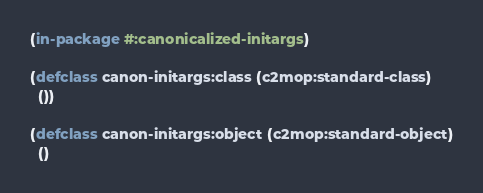<code> <loc_0><loc_0><loc_500><loc_500><_Lisp_>(in-package #:canonicalized-initargs)

(defclass canon-initargs:class (c2mop:standard-class)
  ())

(defclass canon-initargs:object (c2mop:standard-object)
  ()</code> 